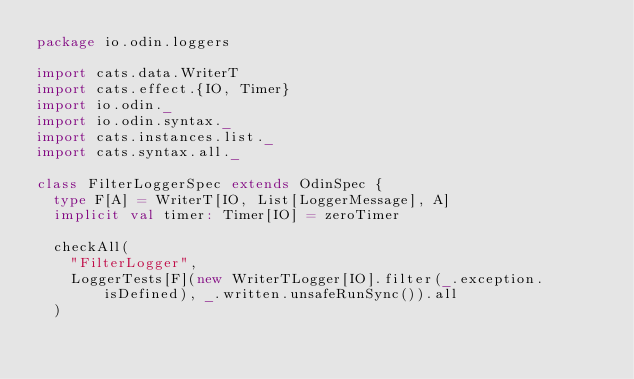<code> <loc_0><loc_0><loc_500><loc_500><_Scala_>package io.odin.loggers

import cats.data.WriterT
import cats.effect.{IO, Timer}
import io.odin._
import io.odin.syntax._
import cats.instances.list._
import cats.syntax.all._

class FilterLoggerSpec extends OdinSpec {
  type F[A] = WriterT[IO, List[LoggerMessage], A]
  implicit val timer: Timer[IO] = zeroTimer

  checkAll(
    "FilterLogger",
    LoggerTests[F](new WriterTLogger[IO].filter(_.exception.isDefined), _.written.unsafeRunSync()).all
  )
</code> 